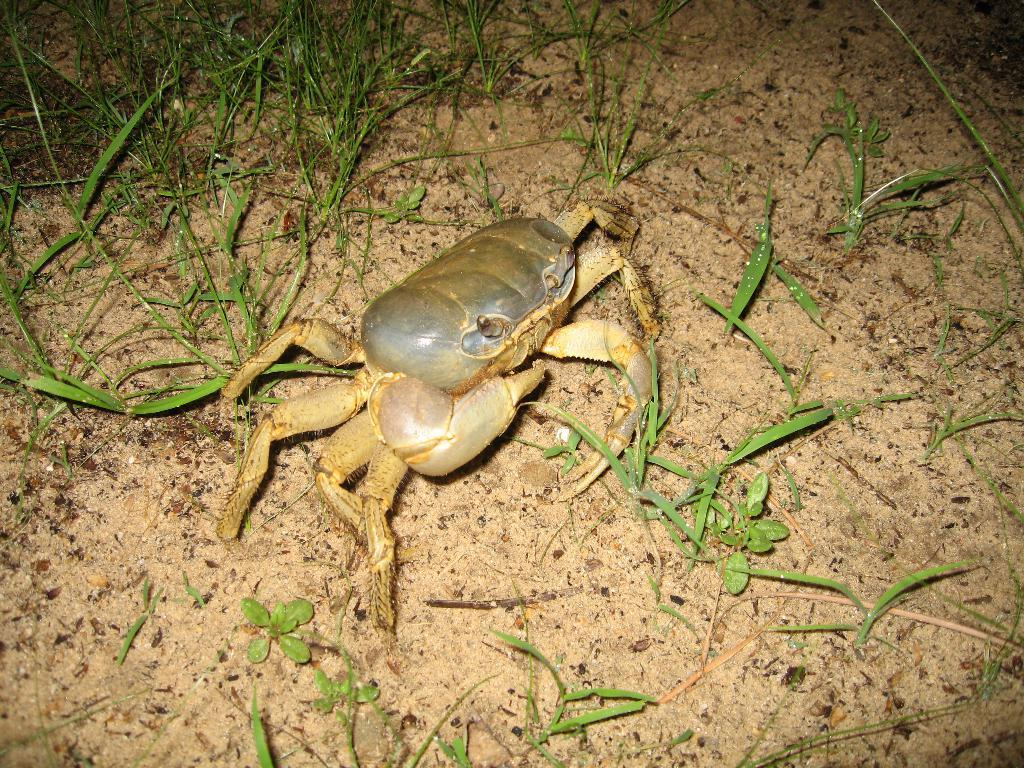What type of animal is in the image? There is a crab in the image. What type of terrain is visible in the image? There is grass and sand visible in the image. Where is the grass located in the image? The grass is present in the background of the image. What type of lace can be seen on the crab's back in the image? There is no lace present on the crab's back in the image. How many birds are in the flock that is visible in the image? There is no flock of birds visible in the image; it features a crab and grass in the background. 